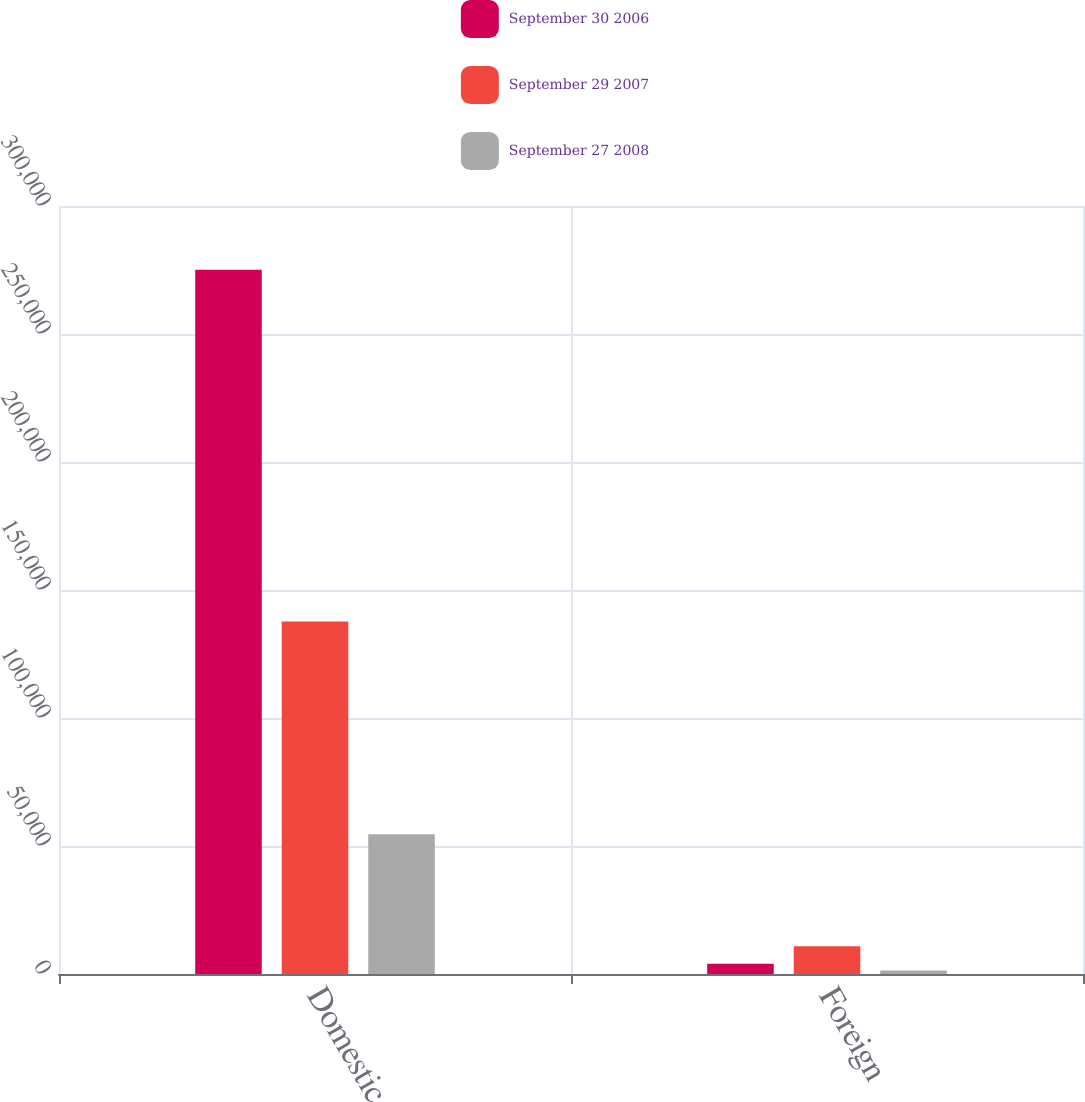Convert chart to OTSL. <chart><loc_0><loc_0><loc_500><loc_500><stacked_bar_chart><ecel><fcel>Domestic<fcel>Foreign<nl><fcel>September 30 2006<fcel>275091<fcel>4050<nl><fcel>September 29 2007<fcel>137659<fcel>10830<nl><fcel>September 27 2008<fcel>54542<fcel>1319<nl></chart> 